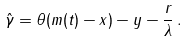Convert formula to latex. <formula><loc_0><loc_0><loc_500><loc_500>\hat { \gamma } = \theta ( m ( t ) - x ) - y - \frac { r } { \lambda } \, .</formula> 